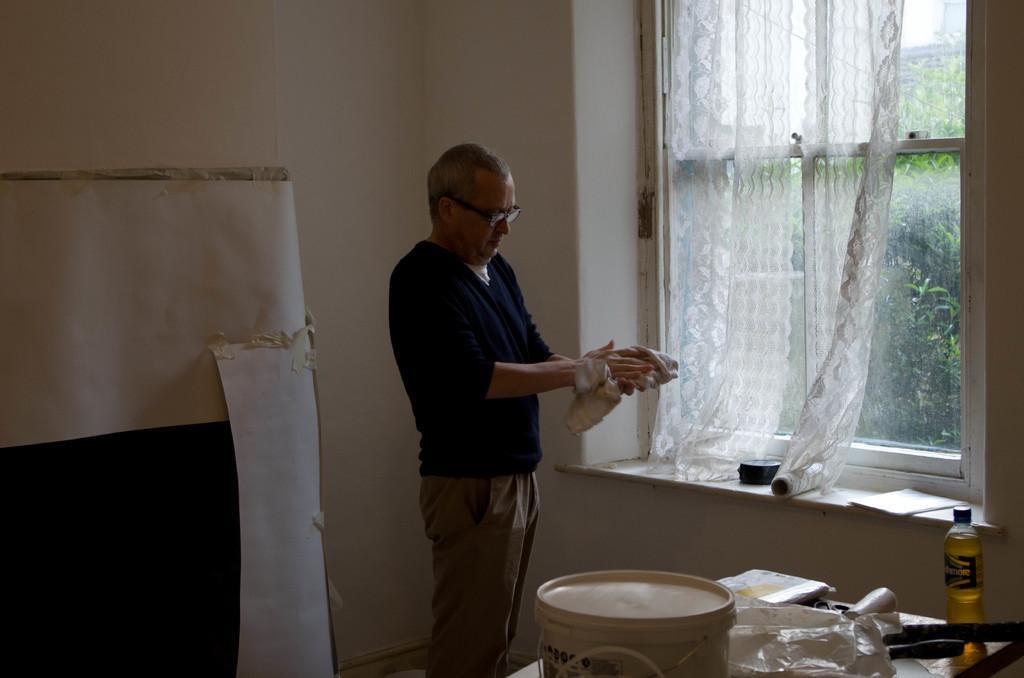Could you give a brief overview of what you see in this image? In the center of the image there is a person standing and holding cloth. At the bottom of the image we can see tub, bottle and cover placed on the table. In the background we can see trees, window, curtain and wall. 